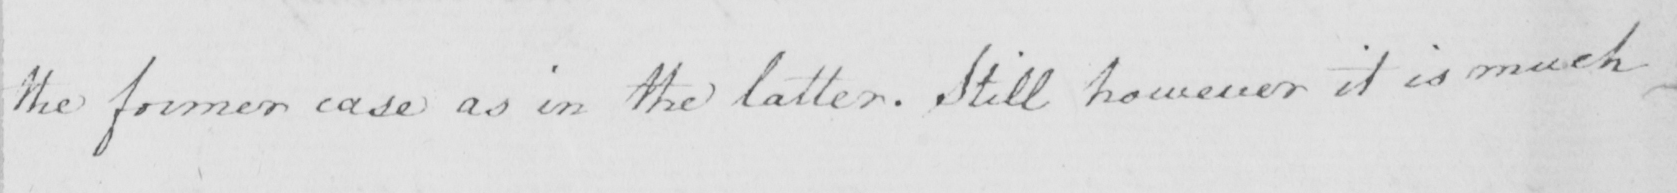Transcribe the text shown in this historical manuscript line. the former case as in the latter . Still however it is much 